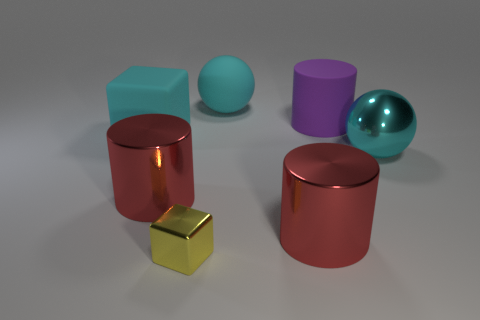There is a cyan matte object in front of the matte thing that is to the right of the large matte ball; are there any cyan metal objects behind it?
Your answer should be very brief. No. Is there a yellow shiny object?
Make the answer very short. Yes. Are there more large red shiny things in front of the large purple thing than big cyan metal objects left of the big cyan matte cube?
Your response must be concise. Yes. What is the size of the cyan ball that is the same material as the big purple cylinder?
Keep it short and to the point. Large. How big is the cube that is behind the large ball in front of the big cyan rubber object on the left side of the tiny cube?
Ensure brevity in your answer.  Large. There is a big cylinder that is left of the large cyan matte ball; what is its color?
Provide a short and direct response. Red. Is the number of purple rubber cylinders to the right of the rubber ball greater than the number of metallic balls?
Offer a very short reply. No. There is a cyan rubber object to the right of the large block; is its shape the same as the tiny yellow object?
Offer a very short reply. No. What number of cyan objects are either big shiny balls or tiny shiny things?
Ensure brevity in your answer.  1. Are there more cyan blocks than small blue rubber objects?
Ensure brevity in your answer.  Yes. 